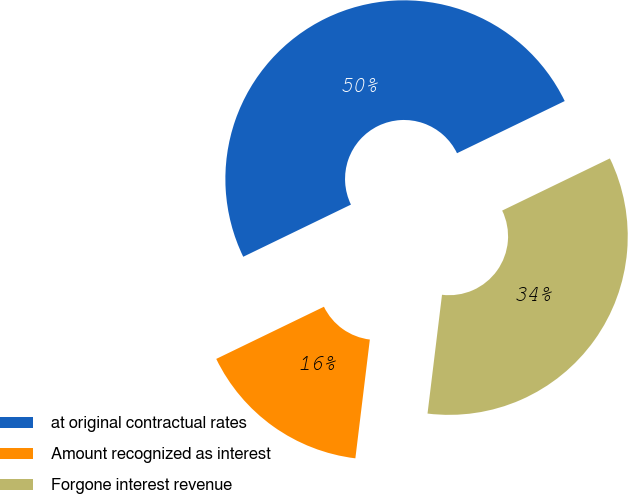<chart> <loc_0><loc_0><loc_500><loc_500><pie_chart><fcel>at original contractual rates<fcel>Amount recognized as interest<fcel>Forgone interest revenue<nl><fcel>50.0%<fcel>15.89%<fcel>34.11%<nl></chart> 